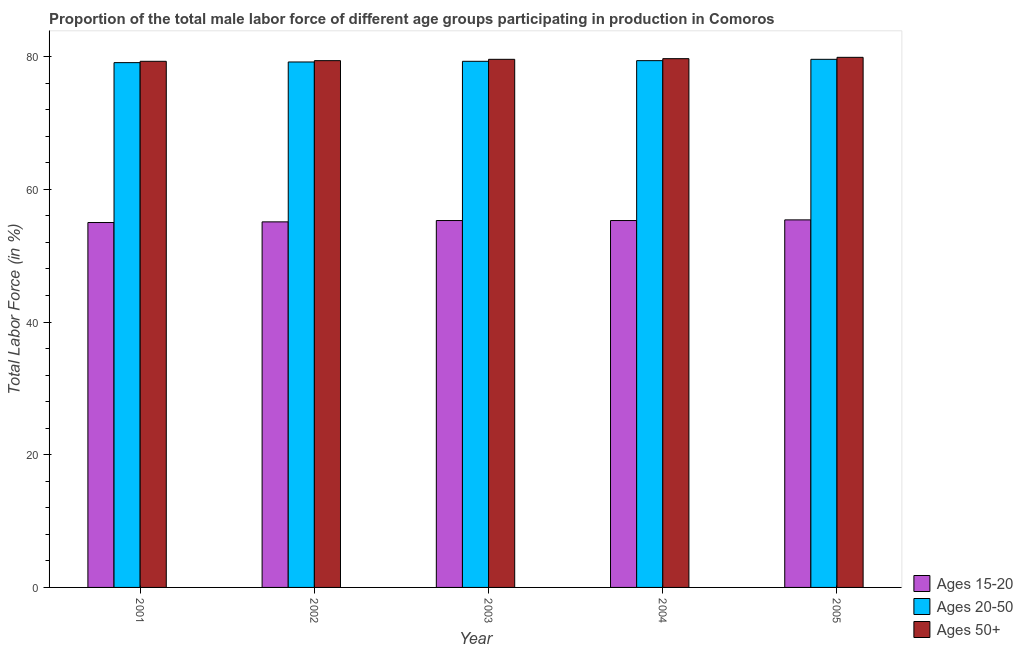How many different coloured bars are there?
Provide a succinct answer. 3. How many groups of bars are there?
Provide a succinct answer. 5. Are the number of bars per tick equal to the number of legend labels?
Provide a succinct answer. Yes. What is the label of the 3rd group of bars from the left?
Provide a short and direct response. 2003. What is the percentage of male labor force within the age group 15-20 in 2002?
Your answer should be very brief. 55.1. Across all years, what is the maximum percentage of male labor force within the age group 20-50?
Keep it short and to the point. 79.6. Across all years, what is the minimum percentage of male labor force above age 50?
Make the answer very short. 79.3. What is the total percentage of male labor force within the age group 15-20 in the graph?
Offer a terse response. 276.1. What is the difference between the percentage of male labor force within the age group 15-20 in 2001 and that in 2003?
Your answer should be very brief. -0.3. What is the difference between the percentage of male labor force within the age group 20-50 in 2004 and the percentage of male labor force within the age group 15-20 in 2005?
Ensure brevity in your answer.  -0.2. What is the average percentage of male labor force within the age group 15-20 per year?
Your answer should be very brief. 55.22. What is the ratio of the percentage of male labor force above age 50 in 2003 to that in 2004?
Make the answer very short. 1. Is the percentage of male labor force above age 50 in 2002 less than that in 2004?
Ensure brevity in your answer.  Yes. Is the difference between the percentage of male labor force above age 50 in 2001 and 2004 greater than the difference between the percentage of male labor force within the age group 15-20 in 2001 and 2004?
Your answer should be compact. No. What is the difference between the highest and the second highest percentage of male labor force within the age group 20-50?
Provide a short and direct response. 0.2. What is the difference between the highest and the lowest percentage of male labor force above age 50?
Offer a very short reply. 0.6. In how many years, is the percentage of male labor force above age 50 greater than the average percentage of male labor force above age 50 taken over all years?
Ensure brevity in your answer.  3. Is the sum of the percentage of male labor force within the age group 20-50 in 2002 and 2004 greater than the maximum percentage of male labor force within the age group 15-20 across all years?
Offer a terse response. Yes. What does the 3rd bar from the left in 2002 represents?
Offer a very short reply. Ages 50+. What does the 3rd bar from the right in 2004 represents?
Your answer should be very brief. Ages 15-20. Is it the case that in every year, the sum of the percentage of male labor force within the age group 15-20 and percentage of male labor force within the age group 20-50 is greater than the percentage of male labor force above age 50?
Your response must be concise. Yes. What is the difference between two consecutive major ticks on the Y-axis?
Make the answer very short. 20. Where does the legend appear in the graph?
Provide a succinct answer. Bottom right. How many legend labels are there?
Keep it short and to the point. 3. How are the legend labels stacked?
Provide a short and direct response. Vertical. What is the title of the graph?
Give a very brief answer. Proportion of the total male labor force of different age groups participating in production in Comoros. Does "Ages 15-64" appear as one of the legend labels in the graph?
Ensure brevity in your answer.  No. What is the label or title of the X-axis?
Your response must be concise. Year. What is the label or title of the Y-axis?
Your answer should be very brief. Total Labor Force (in %). What is the Total Labor Force (in %) of Ages 20-50 in 2001?
Your answer should be compact. 79.1. What is the Total Labor Force (in %) in Ages 50+ in 2001?
Make the answer very short. 79.3. What is the Total Labor Force (in %) of Ages 15-20 in 2002?
Give a very brief answer. 55.1. What is the Total Labor Force (in %) in Ages 20-50 in 2002?
Keep it short and to the point. 79.2. What is the Total Labor Force (in %) of Ages 50+ in 2002?
Keep it short and to the point. 79.4. What is the Total Labor Force (in %) of Ages 15-20 in 2003?
Provide a succinct answer. 55.3. What is the Total Labor Force (in %) of Ages 20-50 in 2003?
Provide a short and direct response. 79.3. What is the Total Labor Force (in %) of Ages 50+ in 2003?
Your answer should be very brief. 79.6. What is the Total Labor Force (in %) in Ages 15-20 in 2004?
Provide a short and direct response. 55.3. What is the Total Labor Force (in %) in Ages 20-50 in 2004?
Give a very brief answer. 79.4. What is the Total Labor Force (in %) in Ages 50+ in 2004?
Give a very brief answer. 79.7. What is the Total Labor Force (in %) in Ages 15-20 in 2005?
Offer a terse response. 55.4. What is the Total Labor Force (in %) in Ages 20-50 in 2005?
Offer a terse response. 79.6. What is the Total Labor Force (in %) in Ages 50+ in 2005?
Your answer should be very brief. 79.9. Across all years, what is the maximum Total Labor Force (in %) of Ages 15-20?
Your answer should be compact. 55.4. Across all years, what is the maximum Total Labor Force (in %) of Ages 20-50?
Give a very brief answer. 79.6. Across all years, what is the maximum Total Labor Force (in %) of Ages 50+?
Ensure brevity in your answer.  79.9. Across all years, what is the minimum Total Labor Force (in %) in Ages 15-20?
Your answer should be very brief. 55. Across all years, what is the minimum Total Labor Force (in %) of Ages 20-50?
Your answer should be compact. 79.1. Across all years, what is the minimum Total Labor Force (in %) in Ages 50+?
Ensure brevity in your answer.  79.3. What is the total Total Labor Force (in %) in Ages 15-20 in the graph?
Give a very brief answer. 276.1. What is the total Total Labor Force (in %) in Ages 20-50 in the graph?
Give a very brief answer. 396.6. What is the total Total Labor Force (in %) in Ages 50+ in the graph?
Keep it short and to the point. 397.9. What is the difference between the Total Labor Force (in %) of Ages 15-20 in 2001 and that in 2002?
Give a very brief answer. -0.1. What is the difference between the Total Labor Force (in %) in Ages 20-50 in 2001 and that in 2002?
Offer a very short reply. -0.1. What is the difference between the Total Labor Force (in %) of Ages 50+ in 2001 and that in 2002?
Your answer should be very brief. -0.1. What is the difference between the Total Labor Force (in %) in Ages 20-50 in 2001 and that in 2003?
Ensure brevity in your answer.  -0.2. What is the difference between the Total Labor Force (in %) of Ages 50+ in 2001 and that in 2003?
Offer a very short reply. -0.3. What is the difference between the Total Labor Force (in %) in Ages 20-50 in 2001 and that in 2004?
Keep it short and to the point. -0.3. What is the difference between the Total Labor Force (in %) in Ages 15-20 in 2001 and that in 2005?
Provide a short and direct response. -0.4. What is the difference between the Total Labor Force (in %) in Ages 20-50 in 2001 and that in 2005?
Ensure brevity in your answer.  -0.5. What is the difference between the Total Labor Force (in %) in Ages 15-20 in 2002 and that in 2003?
Keep it short and to the point. -0.2. What is the difference between the Total Labor Force (in %) in Ages 20-50 in 2002 and that in 2003?
Provide a succinct answer. -0.1. What is the difference between the Total Labor Force (in %) in Ages 50+ in 2002 and that in 2003?
Ensure brevity in your answer.  -0.2. What is the difference between the Total Labor Force (in %) of Ages 50+ in 2002 and that in 2005?
Ensure brevity in your answer.  -0.5. What is the difference between the Total Labor Force (in %) of Ages 50+ in 2003 and that in 2004?
Provide a succinct answer. -0.1. What is the difference between the Total Labor Force (in %) of Ages 15-20 in 2003 and that in 2005?
Provide a short and direct response. -0.1. What is the difference between the Total Labor Force (in %) of Ages 50+ in 2003 and that in 2005?
Offer a terse response. -0.3. What is the difference between the Total Labor Force (in %) of Ages 20-50 in 2004 and that in 2005?
Make the answer very short. -0.2. What is the difference between the Total Labor Force (in %) of Ages 50+ in 2004 and that in 2005?
Your answer should be compact. -0.2. What is the difference between the Total Labor Force (in %) of Ages 15-20 in 2001 and the Total Labor Force (in %) of Ages 20-50 in 2002?
Your response must be concise. -24.2. What is the difference between the Total Labor Force (in %) of Ages 15-20 in 2001 and the Total Labor Force (in %) of Ages 50+ in 2002?
Your answer should be compact. -24.4. What is the difference between the Total Labor Force (in %) in Ages 15-20 in 2001 and the Total Labor Force (in %) in Ages 20-50 in 2003?
Provide a short and direct response. -24.3. What is the difference between the Total Labor Force (in %) in Ages 15-20 in 2001 and the Total Labor Force (in %) in Ages 50+ in 2003?
Offer a very short reply. -24.6. What is the difference between the Total Labor Force (in %) in Ages 20-50 in 2001 and the Total Labor Force (in %) in Ages 50+ in 2003?
Keep it short and to the point. -0.5. What is the difference between the Total Labor Force (in %) of Ages 15-20 in 2001 and the Total Labor Force (in %) of Ages 20-50 in 2004?
Give a very brief answer. -24.4. What is the difference between the Total Labor Force (in %) of Ages 15-20 in 2001 and the Total Labor Force (in %) of Ages 50+ in 2004?
Your answer should be compact. -24.7. What is the difference between the Total Labor Force (in %) in Ages 20-50 in 2001 and the Total Labor Force (in %) in Ages 50+ in 2004?
Your answer should be compact. -0.6. What is the difference between the Total Labor Force (in %) in Ages 15-20 in 2001 and the Total Labor Force (in %) in Ages 20-50 in 2005?
Keep it short and to the point. -24.6. What is the difference between the Total Labor Force (in %) in Ages 15-20 in 2001 and the Total Labor Force (in %) in Ages 50+ in 2005?
Your answer should be compact. -24.9. What is the difference between the Total Labor Force (in %) in Ages 20-50 in 2001 and the Total Labor Force (in %) in Ages 50+ in 2005?
Offer a terse response. -0.8. What is the difference between the Total Labor Force (in %) in Ages 15-20 in 2002 and the Total Labor Force (in %) in Ages 20-50 in 2003?
Give a very brief answer. -24.2. What is the difference between the Total Labor Force (in %) of Ages 15-20 in 2002 and the Total Labor Force (in %) of Ages 50+ in 2003?
Make the answer very short. -24.5. What is the difference between the Total Labor Force (in %) in Ages 15-20 in 2002 and the Total Labor Force (in %) in Ages 20-50 in 2004?
Your answer should be compact. -24.3. What is the difference between the Total Labor Force (in %) in Ages 15-20 in 2002 and the Total Labor Force (in %) in Ages 50+ in 2004?
Provide a succinct answer. -24.6. What is the difference between the Total Labor Force (in %) in Ages 15-20 in 2002 and the Total Labor Force (in %) in Ages 20-50 in 2005?
Offer a very short reply. -24.5. What is the difference between the Total Labor Force (in %) in Ages 15-20 in 2002 and the Total Labor Force (in %) in Ages 50+ in 2005?
Offer a terse response. -24.8. What is the difference between the Total Labor Force (in %) of Ages 15-20 in 2003 and the Total Labor Force (in %) of Ages 20-50 in 2004?
Make the answer very short. -24.1. What is the difference between the Total Labor Force (in %) in Ages 15-20 in 2003 and the Total Labor Force (in %) in Ages 50+ in 2004?
Your answer should be compact. -24.4. What is the difference between the Total Labor Force (in %) in Ages 15-20 in 2003 and the Total Labor Force (in %) in Ages 20-50 in 2005?
Your response must be concise. -24.3. What is the difference between the Total Labor Force (in %) of Ages 15-20 in 2003 and the Total Labor Force (in %) of Ages 50+ in 2005?
Provide a succinct answer. -24.6. What is the difference between the Total Labor Force (in %) of Ages 15-20 in 2004 and the Total Labor Force (in %) of Ages 20-50 in 2005?
Ensure brevity in your answer.  -24.3. What is the difference between the Total Labor Force (in %) in Ages 15-20 in 2004 and the Total Labor Force (in %) in Ages 50+ in 2005?
Keep it short and to the point. -24.6. What is the average Total Labor Force (in %) of Ages 15-20 per year?
Provide a succinct answer. 55.22. What is the average Total Labor Force (in %) in Ages 20-50 per year?
Ensure brevity in your answer.  79.32. What is the average Total Labor Force (in %) in Ages 50+ per year?
Keep it short and to the point. 79.58. In the year 2001, what is the difference between the Total Labor Force (in %) of Ages 15-20 and Total Labor Force (in %) of Ages 20-50?
Your answer should be compact. -24.1. In the year 2001, what is the difference between the Total Labor Force (in %) in Ages 15-20 and Total Labor Force (in %) in Ages 50+?
Provide a short and direct response. -24.3. In the year 2002, what is the difference between the Total Labor Force (in %) of Ages 15-20 and Total Labor Force (in %) of Ages 20-50?
Your answer should be very brief. -24.1. In the year 2002, what is the difference between the Total Labor Force (in %) of Ages 15-20 and Total Labor Force (in %) of Ages 50+?
Offer a terse response. -24.3. In the year 2002, what is the difference between the Total Labor Force (in %) of Ages 20-50 and Total Labor Force (in %) of Ages 50+?
Make the answer very short. -0.2. In the year 2003, what is the difference between the Total Labor Force (in %) of Ages 15-20 and Total Labor Force (in %) of Ages 50+?
Your answer should be very brief. -24.3. In the year 2004, what is the difference between the Total Labor Force (in %) in Ages 15-20 and Total Labor Force (in %) in Ages 20-50?
Offer a very short reply. -24.1. In the year 2004, what is the difference between the Total Labor Force (in %) of Ages 15-20 and Total Labor Force (in %) of Ages 50+?
Keep it short and to the point. -24.4. In the year 2004, what is the difference between the Total Labor Force (in %) in Ages 20-50 and Total Labor Force (in %) in Ages 50+?
Offer a very short reply. -0.3. In the year 2005, what is the difference between the Total Labor Force (in %) of Ages 15-20 and Total Labor Force (in %) of Ages 20-50?
Your answer should be compact. -24.2. In the year 2005, what is the difference between the Total Labor Force (in %) in Ages 15-20 and Total Labor Force (in %) in Ages 50+?
Provide a short and direct response. -24.5. What is the ratio of the Total Labor Force (in %) in Ages 20-50 in 2001 to that in 2002?
Your answer should be very brief. 1. What is the ratio of the Total Labor Force (in %) in Ages 15-20 in 2001 to that in 2003?
Offer a terse response. 0.99. What is the ratio of the Total Labor Force (in %) in Ages 20-50 in 2001 to that in 2004?
Offer a terse response. 1. What is the ratio of the Total Labor Force (in %) in Ages 50+ in 2001 to that in 2004?
Provide a succinct answer. 0.99. What is the ratio of the Total Labor Force (in %) in Ages 15-20 in 2001 to that in 2005?
Offer a very short reply. 0.99. What is the ratio of the Total Labor Force (in %) in Ages 20-50 in 2001 to that in 2005?
Your response must be concise. 0.99. What is the ratio of the Total Labor Force (in %) in Ages 15-20 in 2002 to that in 2004?
Provide a short and direct response. 1. What is the ratio of the Total Labor Force (in %) of Ages 50+ in 2002 to that in 2004?
Ensure brevity in your answer.  1. What is the ratio of the Total Labor Force (in %) in Ages 20-50 in 2002 to that in 2005?
Provide a succinct answer. 0.99. What is the ratio of the Total Labor Force (in %) in Ages 50+ in 2002 to that in 2005?
Provide a short and direct response. 0.99. What is the ratio of the Total Labor Force (in %) in Ages 15-20 in 2003 to that in 2005?
Your response must be concise. 1. What is the ratio of the Total Labor Force (in %) of Ages 15-20 in 2004 to that in 2005?
Ensure brevity in your answer.  1. What is the ratio of the Total Labor Force (in %) in Ages 50+ in 2004 to that in 2005?
Your response must be concise. 1. What is the difference between the highest and the second highest Total Labor Force (in %) of Ages 15-20?
Provide a short and direct response. 0.1. What is the difference between the highest and the second highest Total Labor Force (in %) in Ages 20-50?
Offer a terse response. 0.2. What is the difference between the highest and the second highest Total Labor Force (in %) of Ages 50+?
Offer a terse response. 0.2. What is the difference between the highest and the lowest Total Labor Force (in %) in Ages 50+?
Your answer should be very brief. 0.6. 